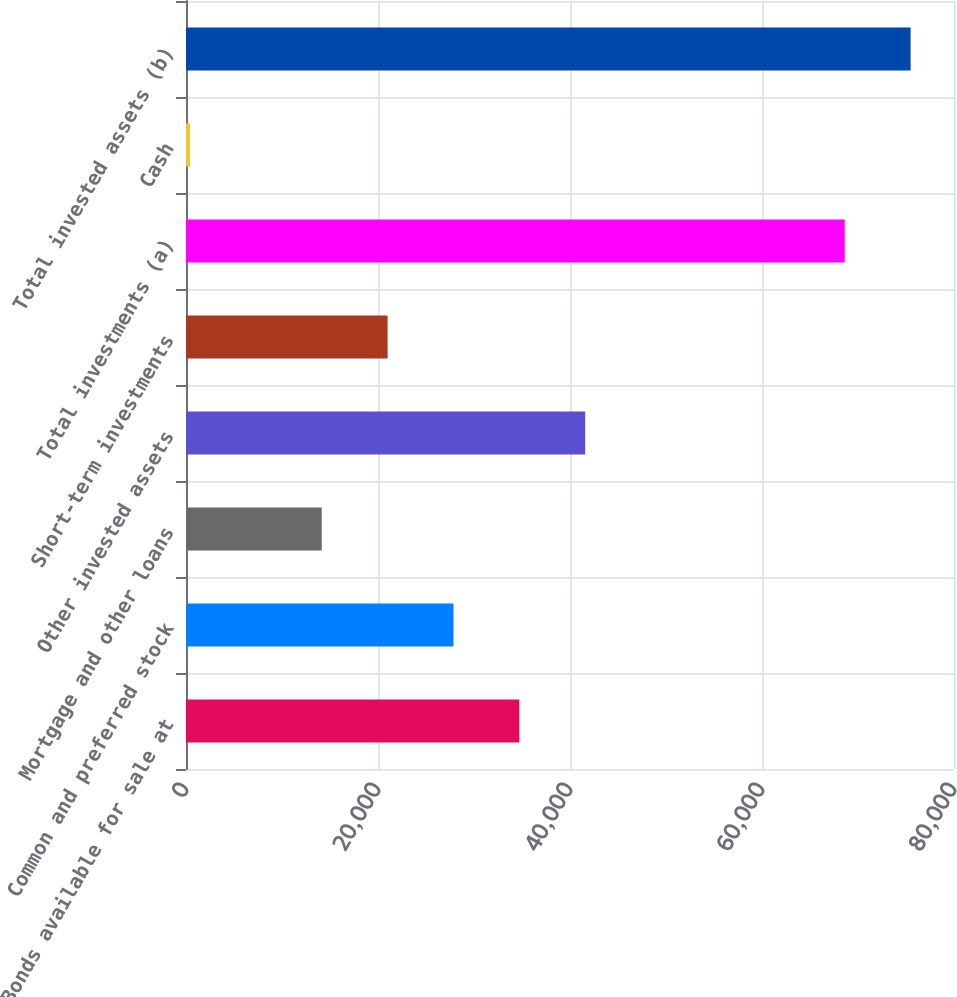Convert chart. <chart><loc_0><loc_0><loc_500><loc_500><bar_chart><fcel>Bonds available for sale at<fcel>Common and preferred stock<fcel>Mortgage and other loans<fcel>Other invested assets<fcel>Short-term investments<fcel>Total investments (a)<fcel>Cash<fcel>Total invested assets (b)<nl><fcel>34723.5<fcel>27861.6<fcel>14137.8<fcel>41585.4<fcel>20999.7<fcel>68619<fcel>414<fcel>75480.9<nl></chart> 